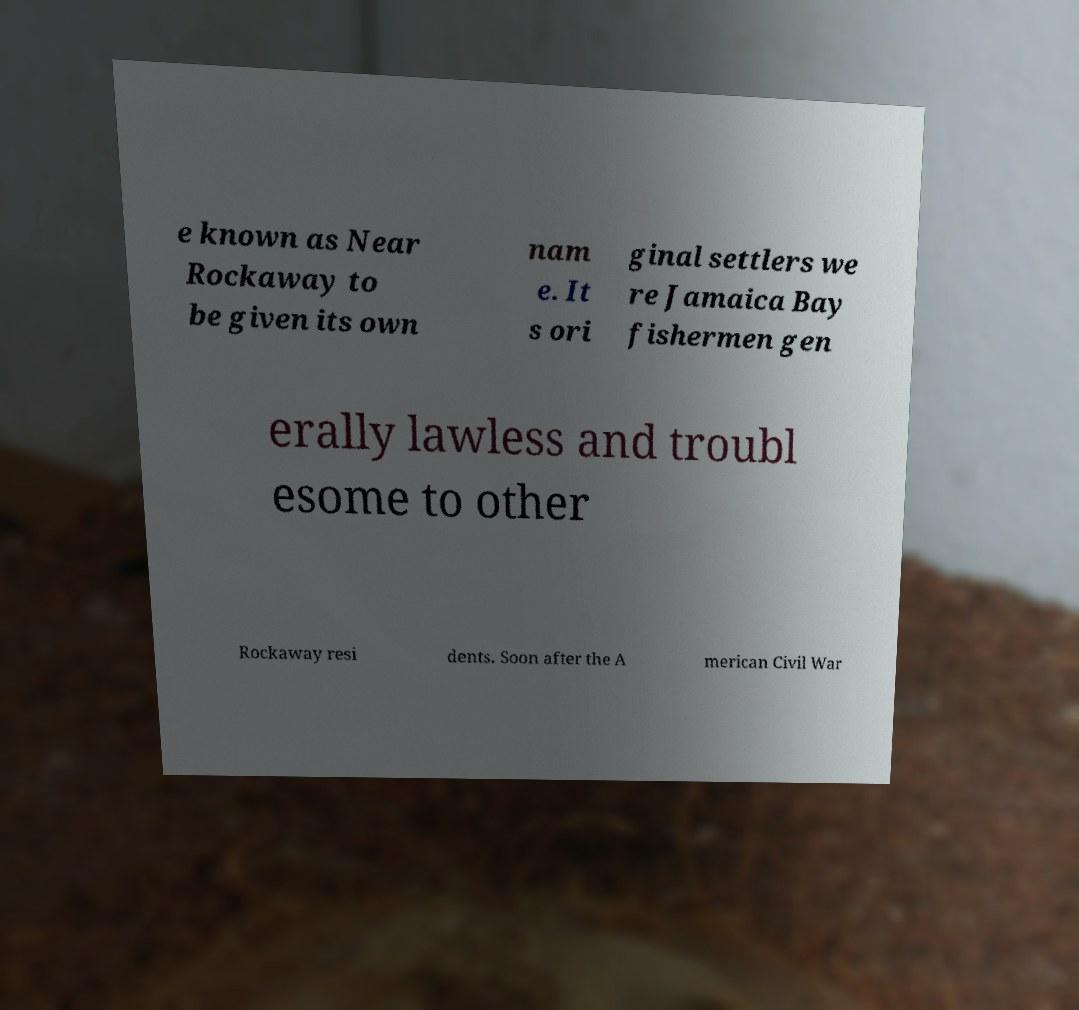What messages or text are displayed in this image? I need them in a readable, typed format. e known as Near Rockaway to be given its own nam e. It s ori ginal settlers we re Jamaica Bay fishermen gen erally lawless and troubl esome to other Rockaway resi dents. Soon after the A merican Civil War 